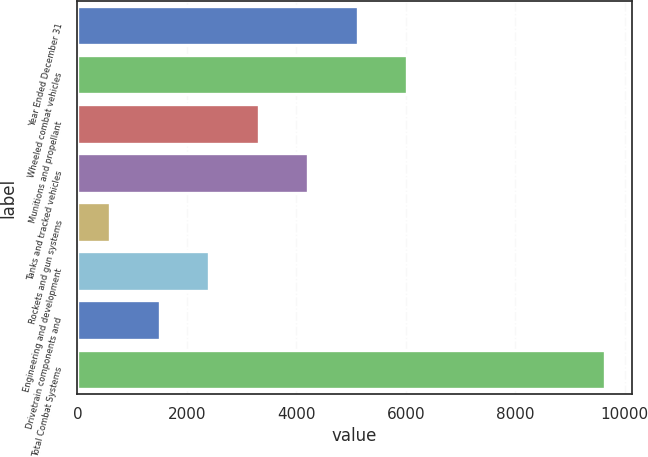Convert chart to OTSL. <chart><loc_0><loc_0><loc_500><loc_500><bar_chart><fcel>Year Ended December 31<fcel>Wheeled combat vehicles<fcel>Munitions and propellant<fcel>Tanks and tracked vehicles<fcel>Rockets and gun systems<fcel>Engineering and development<fcel>Drivetrain components and<fcel>Total Combat Systems<nl><fcel>5120<fcel>6025<fcel>3310<fcel>4215<fcel>595<fcel>2405<fcel>1500<fcel>9645<nl></chart> 